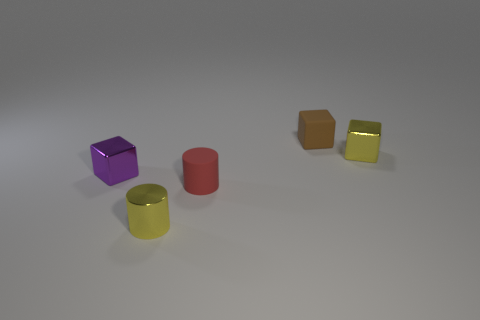Subtract all small metallic cubes. How many cubes are left? 1 Add 1 blue matte cylinders. How many objects exist? 6 Subtract all cylinders. How many objects are left? 3 Add 3 metallic blocks. How many metallic blocks exist? 5 Subtract 0 green cubes. How many objects are left? 5 Subtract all yellow metal blocks. Subtract all gray objects. How many objects are left? 4 Add 4 rubber things. How many rubber things are left? 6 